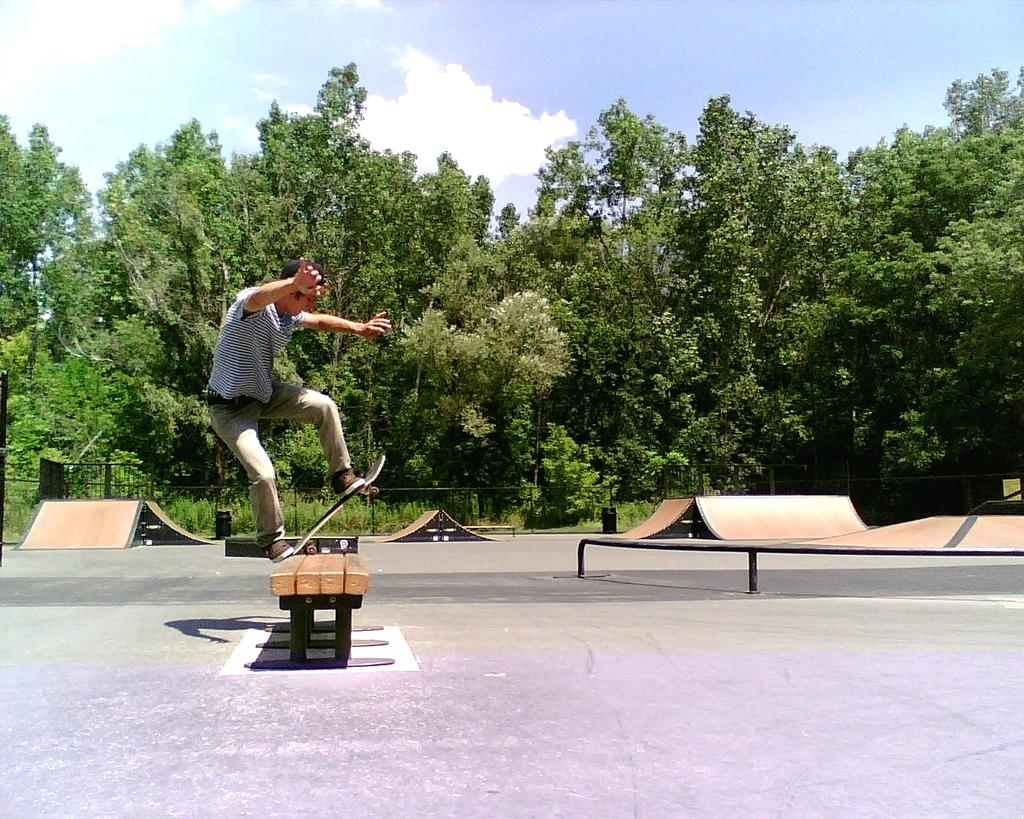What is the person in the image doing? The person is skating on a skateboard. What type of clothing is the person wearing? The person is wearing a t-shirt, trousers, and shoes. What can be seen in the background of the image? There are trees visible in the background of the image. What is visible at the top of the image? The sky is visible at the top of the image. Can you tell me how many goldfish are swimming in the image? There are no goldfish present in the image. What type of baby is shown in the image? There is no baby present in the image. 